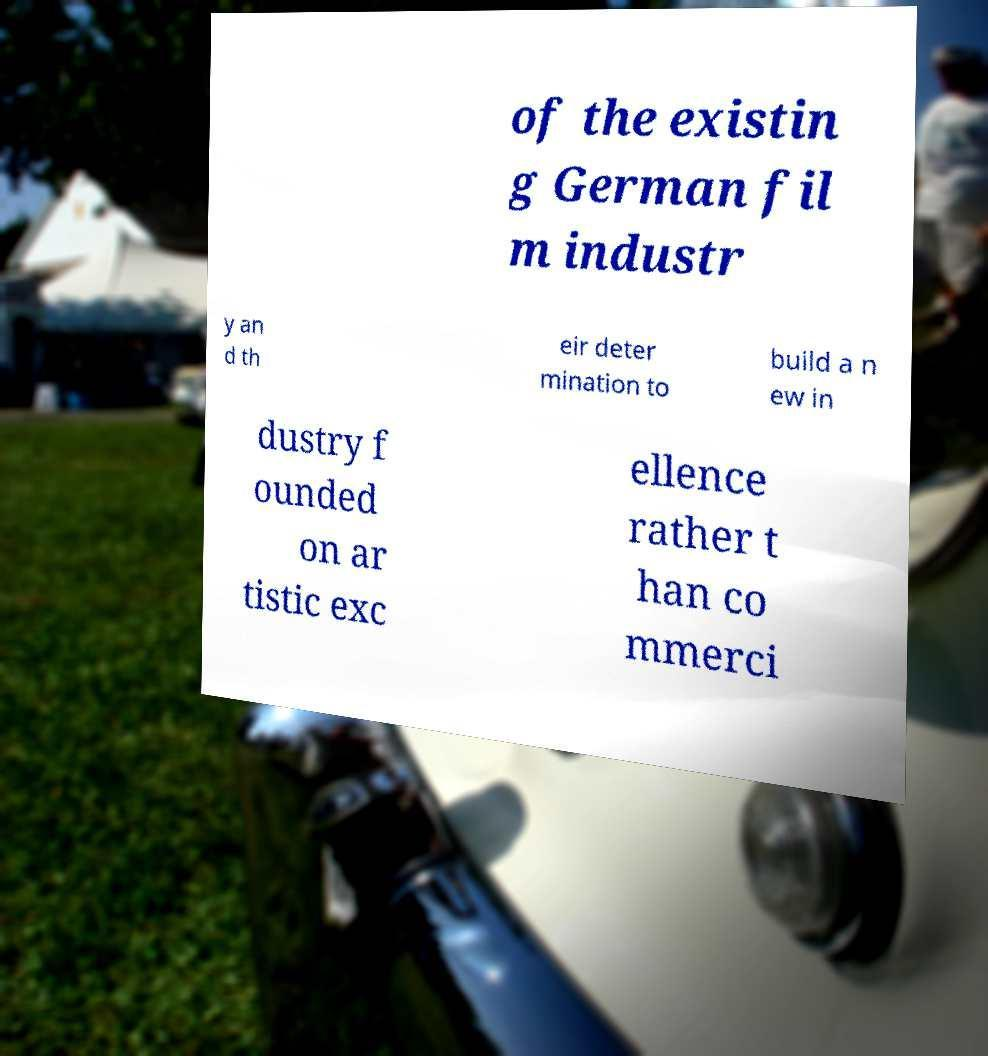Can you read and provide the text displayed in the image?This photo seems to have some interesting text. Can you extract and type it out for me? of the existin g German fil m industr y an d th eir deter mination to build a n ew in dustry f ounded on ar tistic exc ellence rather t han co mmerci 